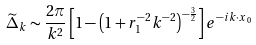Convert formula to latex. <formula><loc_0><loc_0><loc_500><loc_500>\widetilde { \Delta } _ { k } \sim \frac { 2 \pi } { k ^ { 2 } } \left [ 1 - \left ( 1 + r _ { 1 } ^ { - 2 } k ^ { - 2 } \right ) ^ { - \frac { 3 } { 2 } } \right ] e ^ { - i { k \cdot x } _ { 0 } }</formula> 